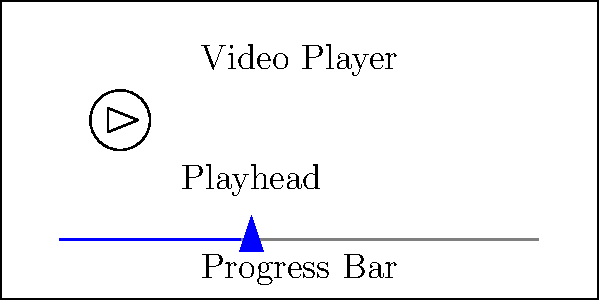In implementing a basic video playback control system with a progress bar, which event listener should be used to update the progress bar's position as the video plays, and what property of the video element would you use to calculate the current progress? To implement a basic video playback control system with a progress bar, follow these steps:

1. Create an HTML5 video element and a progress bar element in your markup.

2. In JavaScript, add an event listener to the video element for the 'timeupdate' event. This event fires periodically as the video plays, allowing you to update the progress bar.

3. Inside the event listener callback function, calculate the current progress as a percentage:
   $$ \text{progress} = \frac{\text{currentTime}}{\text{duration}} \times 100 $$

4. Use the video element's 'currentTime' property to get the current playback position in seconds.

5. Use the video element's 'duration' property to get the total length of the video in seconds.

6. Update the progress bar's width or position based on the calculated percentage.

The key components for updating the progress bar are:
- Event listener: 'timeupdate'
- Video property for current position: 'currentTime'
Answer: 'timeupdate' event and 'currentTime' property 